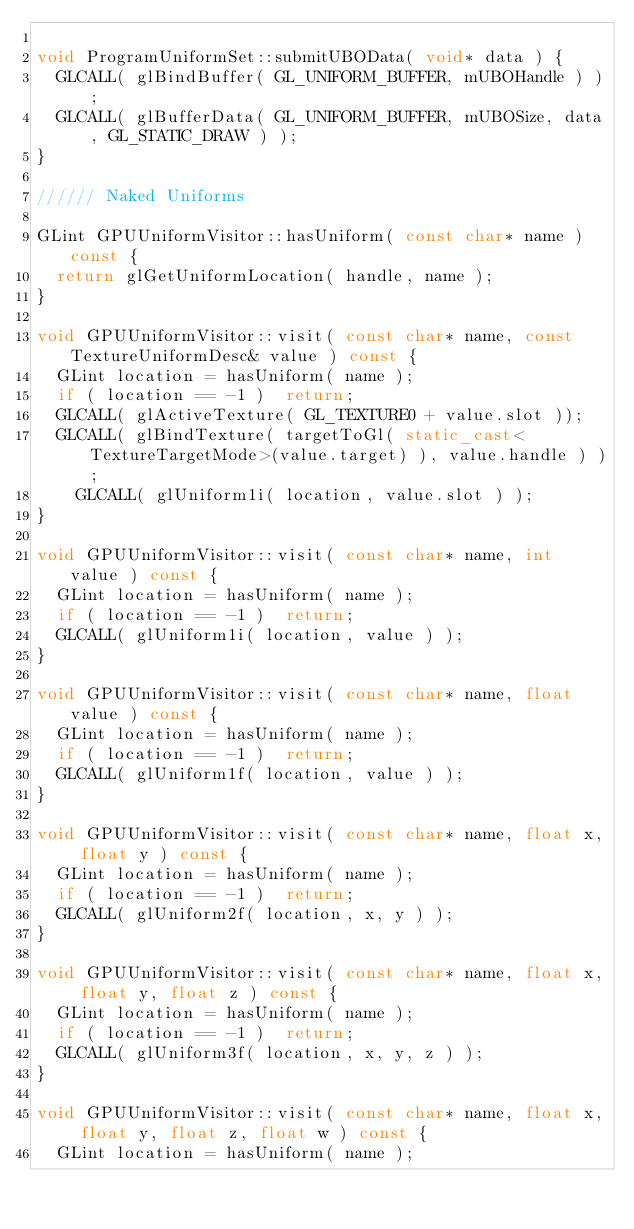Convert code to text. <code><loc_0><loc_0><loc_500><loc_500><_C++_>
void ProgramUniformSet::submitUBOData( void* data ) {
	GLCALL( glBindBuffer( GL_UNIFORM_BUFFER, mUBOHandle ) );
	GLCALL( glBufferData( GL_UNIFORM_BUFFER, mUBOSize, data, GL_STATIC_DRAW ) );
}

////// Naked Uniforms

GLint GPUUniformVisitor::hasUniform( const char* name ) const {
	return glGetUniformLocation( handle, name );
}

void GPUUniformVisitor::visit( const char* name, const TextureUniformDesc& value ) const {
	GLint location = hasUniform( name );
	if ( location == -1 )  return;
	GLCALL( glActiveTexture( GL_TEXTURE0 + value.slot ));
	GLCALL( glBindTexture( targetToGl( static_cast<TextureTargetMode>(value.target) ), value.handle ) );
    GLCALL( glUniform1i( location, value.slot ) );
}

void GPUUniformVisitor::visit( const char* name, int value ) const {
	GLint location = hasUniform( name );
	if ( location == -1 )  return;
	GLCALL( glUniform1i( location, value ) );
}

void GPUUniformVisitor::visit( const char* name, float value ) const {
	GLint location = hasUniform( name );
	if ( location == -1 )  return;
	GLCALL( glUniform1f( location, value ) );
}

void GPUUniformVisitor::visit( const char* name, float x, float y ) const {
	GLint location = hasUniform( name );
	if ( location == -1 )  return;
	GLCALL( glUniform2f( location, x, y ) );
}

void GPUUniformVisitor::visit( const char* name, float x, float y, float z ) const {
	GLint location = hasUniform( name );
	if ( location == -1 )  return;
	GLCALL( glUniform3f( location, x, y, z ) );
}

void GPUUniformVisitor::visit( const char* name, float x, float y, float z, float w ) const {
	GLint location = hasUniform( name );</code> 